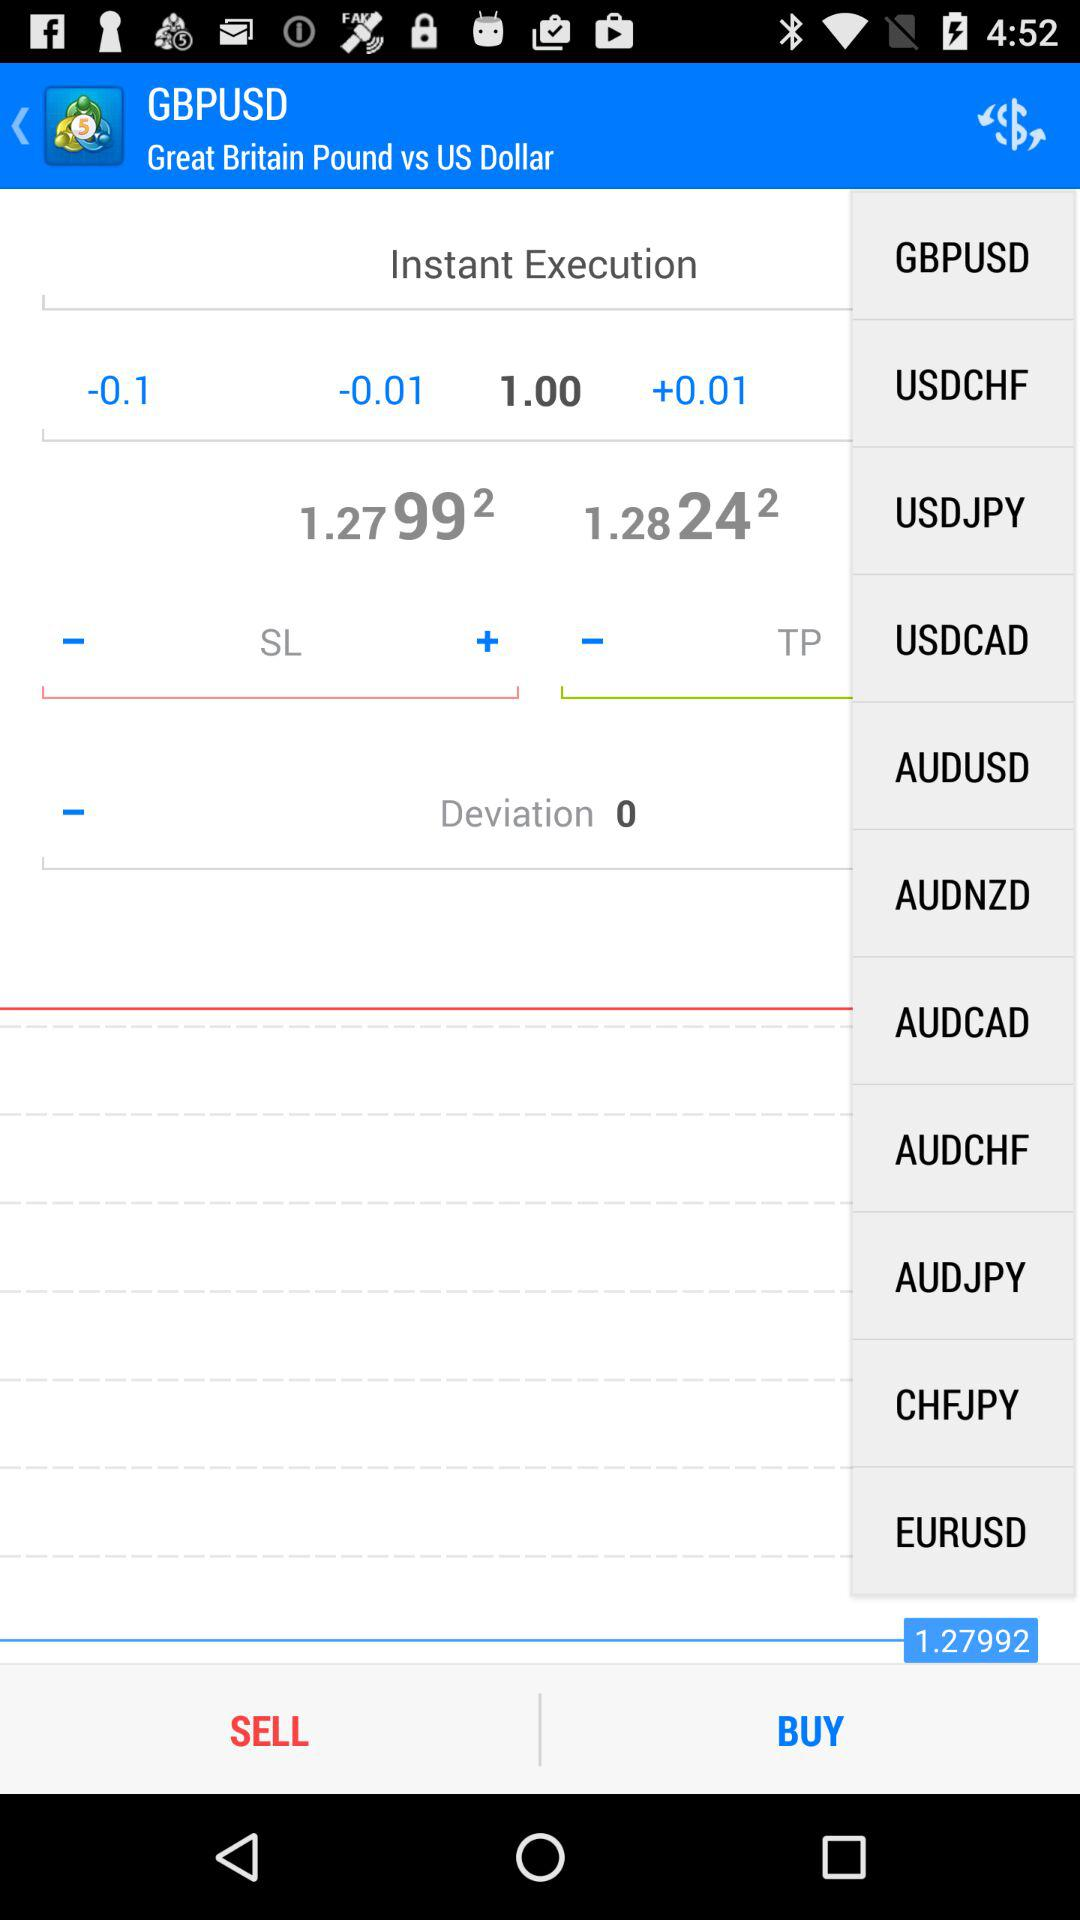Which currency rates are displayed and compared? The currency rates are the Great Britain Pound and the US Dollar. 